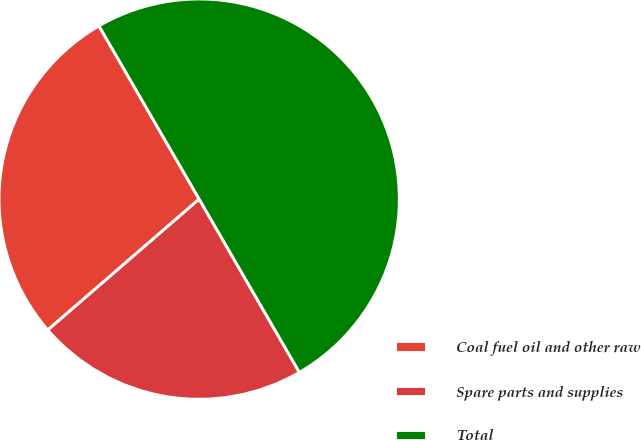Convert chart. <chart><loc_0><loc_0><loc_500><loc_500><pie_chart><fcel>Coal fuel oil and other raw<fcel>Spare parts and supplies<fcel>Total<nl><fcel>28.0%<fcel>22.0%<fcel>50.0%<nl></chart> 